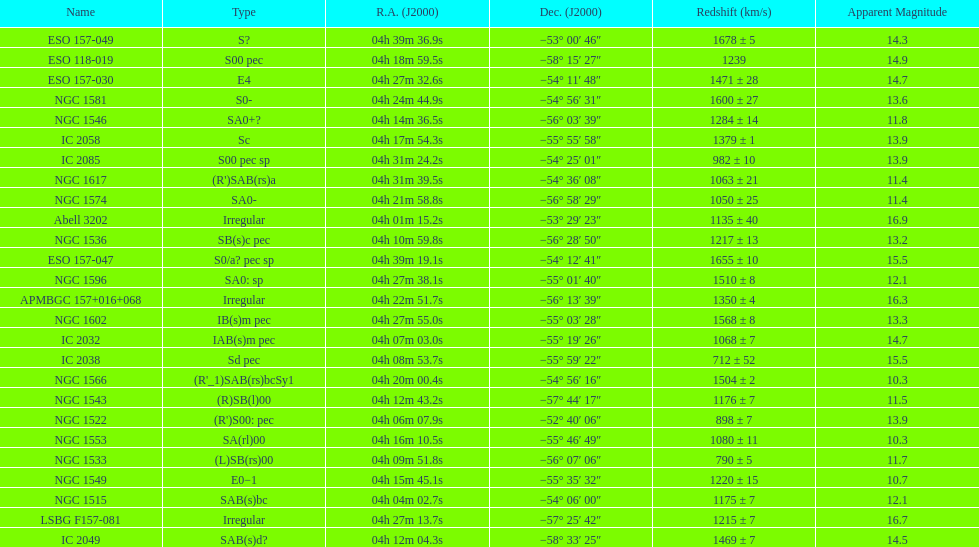What number of "irregular" types are there? 3. 